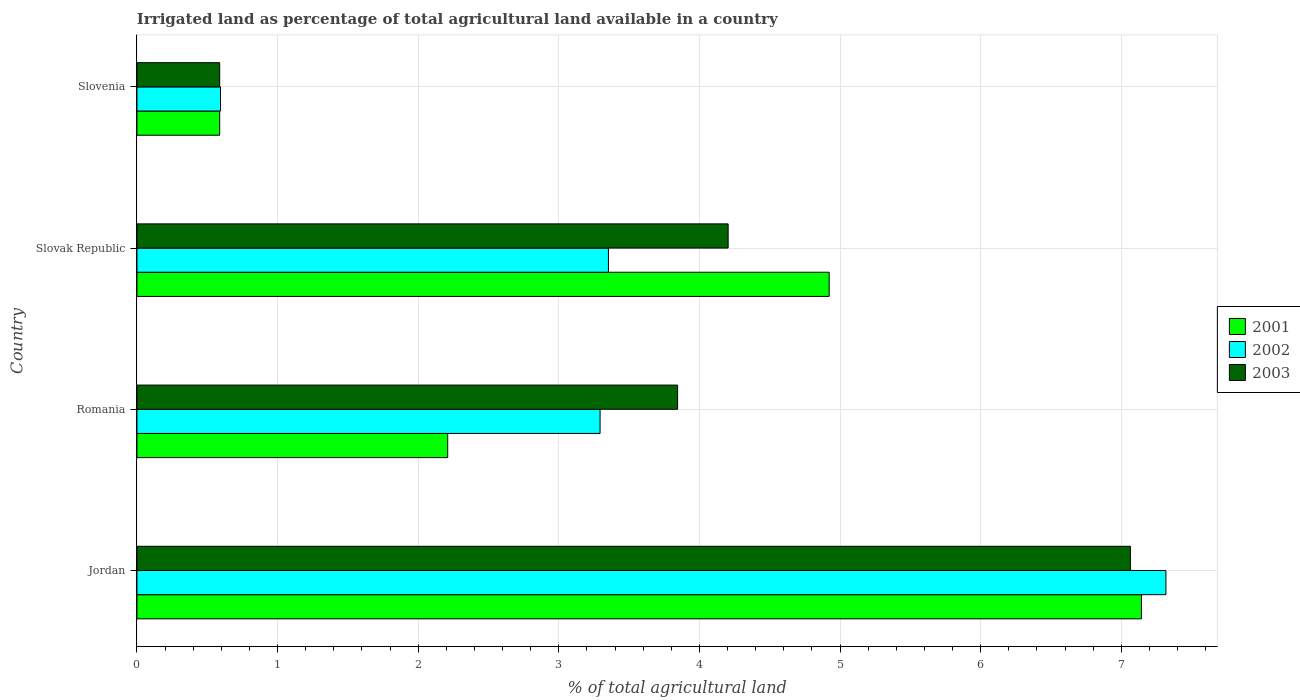Are the number of bars per tick equal to the number of legend labels?
Make the answer very short. Yes. What is the label of the 3rd group of bars from the top?
Your answer should be compact. Romania. In how many cases, is the number of bars for a given country not equal to the number of legend labels?
Provide a succinct answer. 0. What is the percentage of irrigated land in 2002 in Slovak Republic?
Provide a short and direct response. 3.35. Across all countries, what is the maximum percentage of irrigated land in 2001?
Offer a very short reply. 7.14. Across all countries, what is the minimum percentage of irrigated land in 2003?
Offer a very short reply. 0.59. In which country was the percentage of irrigated land in 2001 maximum?
Offer a terse response. Jordan. In which country was the percentage of irrigated land in 2001 minimum?
Your answer should be very brief. Slovenia. What is the total percentage of irrigated land in 2003 in the graph?
Provide a succinct answer. 15.7. What is the difference between the percentage of irrigated land in 2003 in Jordan and that in Romania?
Your answer should be compact. 3.22. What is the difference between the percentage of irrigated land in 2003 in Jordan and the percentage of irrigated land in 2002 in Slovenia?
Your response must be concise. 6.47. What is the average percentage of irrigated land in 2002 per country?
Give a very brief answer. 3.64. What is the difference between the percentage of irrigated land in 2003 and percentage of irrigated land in 2001 in Slovenia?
Provide a succinct answer. 0. In how many countries, is the percentage of irrigated land in 2003 greater than 3.4 %?
Your answer should be compact. 3. What is the ratio of the percentage of irrigated land in 2003 in Jordan to that in Slovenia?
Provide a short and direct response. 12.01. Is the difference between the percentage of irrigated land in 2003 in Slovak Republic and Slovenia greater than the difference between the percentage of irrigated land in 2001 in Slovak Republic and Slovenia?
Provide a short and direct response. No. What is the difference between the highest and the second highest percentage of irrigated land in 2003?
Make the answer very short. 2.86. What is the difference between the highest and the lowest percentage of irrigated land in 2001?
Offer a terse response. 6.55. In how many countries, is the percentage of irrigated land in 2003 greater than the average percentage of irrigated land in 2003 taken over all countries?
Ensure brevity in your answer.  2. What does the 2nd bar from the top in Jordan represents?
Offer a very short reply. 2002. Is it the case that in every country, the sum of the percentage of irrigated land in 2001 and percentage of irrigated land in 2003 is greater than the percentage of irrigated land in 2002?
Your answer should be very brief. Yes. How many bars are there?
Ensure brevity in your answer.  12. How many countries are there in the graph?
Keep it short and to the point. 4. Are the values on the major ticks of X-axis written in scientific E-notation?
Give a very brief answer. No. What is the title of the graph?
Keep it short and to the point. Irrigated land as percentage of total agricultural land available in a country. Does "2009" appear as one of the legend labels in the graph?
Your answer should be very brief. No. What is the label or title of the X-axis?
Make the answer very short. % of total agricultural land. What is the % of total agricultural land of 2001 in Jordan?
Provide a succinct answer. 7.14. What is the % of total agricultural land in 2002 in Jordan?
Keep it short and to the point. 7.32. What is the % of total agricultural land in 2003 in Jordan?
Provide a short and direct response. 7.06. What is the % of total agricultural land of 2001 in Romania?
Provide a short and direct response. 2.21. What is the % of total agricultural land in 2002 in Romania?
Ensure brevity in your answer.  3.29. What is the % of total agricultural land in 2003 in Romania?
Offer a terse response. 3.84. What is the % of total agricultural land in 2001 in Slovak Republic?
Provide a short and direct response. 4.92. What is the % of total agricultural land in 2002 in Slovak Republic?
Provide a short and direct response. 3.35. What is the % of total agricultural land of 2003 in Slovak Republic?
Offer a terse response. 4.2. What is the % of total agricultural land of 2001 in Slovenia?
Your response must be concise. 0.59. What is the % of total agricultural land in 2002 in Slovenia?
Provide a succinct answer. 0.59. What is the % of total agricultural land of 2003 in Slovenia?
Give a very brief answer. 0.59. Across all countries, what is the maximum % of total agricultural land in 2001?
Provide a succinct answer. 7.14. Across all countries, what is the maximum % of total agricultural land of 2002?
Provide a short and direct response. 7.32. Across all countries, what is the maximum % of total agricultural land in 2003?
Offer a very short reply. 7.06. Across all countries, what is the minimum % of total agricultural land of 2001?
Provide a succinct answer. 0.59. Across all countries, what is the minimum % of total agricultural land in 2002?
Make the answer very short. 0.59. Across all countries, what is the minimum % of total agricultural land in 2003?
Give a very brief answer. 0.59. What is the total % of total agricultural land of 2001 in the graph?
Ensure brevity in your answer.  14.86. What is the total % of total agricultural land of 2002 in the graph?
Your answer should be very brief. 14.56. What is the total % of total agricultural land in 2003 in the graph?
Your response must be concise. 15.7. What is the difference between the % of total agricultural land in 2001 in Jordan and that in Romania?
Give a very brief answer. 4.93. What is the difference between the % of total agricultural land in 2002 in Jordan and that in Romania?
Make the answer very short. 4.02. What is the difference between the % of total agricultural land of 2003 in Jordan and that in Romania?
Offer a very short reply. 3.22. What is the difference between the % of total agricultural land in 2001 in Jordan and that in Slovak Republic?
Your response must be concise. 2.22. What is the difference between the % of total agricultural land of 2002 in Jordan and that in Slovak Republic?
Offer a terse response. 3.96. What is the difference between the % of total agricultural land of 2003 in Jordan and that in Slovak Republic?
Give a very brief answer. 2.86. What is the difference between the % of total agricultural land of 2001 in Jordan and that in Slovenia?
Keep it short and to the point. 6.55. What is the difference between the % of total agricultural land of 2002 in Jordan and that in Slovenia?
Your answer should be very brief. 6.72. What is the difference between the % of total agricultural land of 2003 in Jordan and that in Slovenia?
Your answer should be very brief. 6.48. What is the difference between the % of total agricultural land in 2001 in Romania and that in Slovak Republic?
Provide a succinct answer. -2.71. What is the difference between the % of total agricultural land in 2002 in Romania and that in Slovak Republic?
Give a very brief answer. -0.06. What is the difference between the % of total agricultural land in 2003 in Romania and that in Slovak Republic?
Ensure brevity in your answer.  -0.36. What is the difference between the % of total agricultural land in 2001 in Romania and that in Slovenia?
Give a very brief answer. 1.62. What is the difference between the % of total agricultural land in 2002 in Romania and that in Slovenia?
Provide a succinct answer. 2.7. What is the difference between the % of total agricultural land of 2003 in Romania and that in Slovenia?
Provide a succinct answer. 3.26. What is the difference between the % of total agricultural land of 2001 in Slovak Republic and that in Slovenia?
Your answer should be very brief. 4.33. What is the difference between the % of total agricultural land of 2002 in Slovak Republic and that in Slovenia?
Keep it short and to the point. 2.76. What is the difference between the % of total agricultural land in 2003 in Slovak Republic and that in Slovenia?
Ensure brevity in your answer.  3.62. What is the difference between the % of total agricultural land of 2001 in Jordan and the % of total agricultural land of 2002 in Romania?
Keep it short and to the point. 3.85. What is the difference between the % of total agricultural land in 2001 in Jordan and the % of total agricultural land in 2003 in Romania?
Your answer should be very brief. 3.3. What is the difference between the % of total agricultural land in 2002 in Jordan and the % of total agricultural land in 2003 in Romania?
Offer a terse response. 3.47. What is the difference between the % of total agricultural land in 2001 in Jordan and the % of total agricultural land in 2002 in Slovak Republic?
Your answer should be very brief. 3.79. What is the difference between the % of total agricultural land of 2001 in Jordan and the % of total agricultural land of 2003 in Slovak Republic?
Your answer should be very brief. 2.94. What is the difference between the % of total agricultural land of 2002 in Jordan and the % of total agricultural land of 2003 in Slovak Republic?
Your answer should be very brief. 3.11. What is the difference between the % of total agricultural land of 2001 in Jordan and the % of total agricultural land of 2002 in Slovenia?
Your answer should be compact. 6.55. What is the difference between the % of total agricultural land of 2001 in Jordan and the % of total agricultural land of 2003 in Slovenia?
Your response must be concise. 6.55. What is the difference between the % of total agricultural land in 2002 in Jordan and the % of total agricultural land in 2003 in Slovenia?
Offer a very short reply. 6.73. What is the difference between the % of total agricultural land in 2001 in Romania and the % of total agricultural land in 2002 in Slovak Republic?
Make the answer very short. -1.14. What is the difference between the % of total agricultural land in 2001 in Romania and the % of total agricultural land in 2003 in Slovak Republic?
Keep it short and to the point. -1.99. What is the difference between the % of total agricultural land in 2002 in Romania and the % of total agricultural land in 2003 in Slovak Republic?
Your answer should be very brief. -0.91. What is the difference between the % of total agricultural land of 2001 in Romania and the % of total agricultural land of 2002 in Slovenia?
Your answer should be very brief. 1.62. What is the difference between the % of total agricultural land of 2001 in Romania and the % of total agricultural land of 2003 in Slovenia?
Provide a short and direct response. 1.62. What is the difference between the % of total agricultural land in 2002 in Romania and the % of total agricultural land in 2003 in Slovenia?
Keep it short and to the point. 2.71. What is the difference between the % of total agricultural land of 2001 in Slovak Republic and the % of total agricultural land of 2002 in Slovenia?
Provide a short and direct response. 4.33. What is the difference between the % of total agricultural land in 2001 in Slovak Republic and the % of total agricultural land in 2003 in Slovenia?
Give a very brief answer. 4.33. What is the difference between the % of total agricultural land in 2002 in Slovak Republic and the % of total agricultural land in 2003 in Slovenia?
Your response must be concise. 2.76. What is the average % of total agricultural land of 2001 per country?
Keep it short and to the point. 3.72. What is the average % of total agricultural land of 2002 per country?
Offer a terse response. 3.64. What is the average % of total agricultural land in 2003 per country?
Ensure brevity in your answer.  3.93. What is the difference between the % of total agricultural land of 2001 and % of total agricultural land of 2002 in Jordan?
Ensure brevity in your answer.  -0.17. What is the difference between the % of total agricultural land of 2001 and % of total agricultural land of 2003 in Jordan?
Offer a terse response. 0.08. What is the difference between the % of total agricultural land of 2002 and % of total agricultural land of 2003 in Jordan?
Ensure brevity in your answer.  0.25. What is the difference between the % of total agricultural land of 2001 and % of total agricultural land of 2002 in Romania?
Provide a short and direct response. -1.08. What is the difference between the % of total agricultural land in 2001 and % of total agricultural land in 2003 in Romania?
Provide a succinct answer. -1.63. What is the difference between the % of total agricultural land of 2002 and % of total agricultural land of 2003 in Romania?
Offer a terse response. -0.55. What is the difference between the % of total agricultural land in 2001 and % of total agricultural land in 2002 in Slovak Republic?
Your answer should be very brief. 1.57. What is the difference between the % of total agricultural land in 2001 and % of total agricultural land in 2003 in Slovak Republic?
Keep it short and to the point. 0.72. What is the difference between the % of total agricultural land of 2002 and % of total agricultural land of 2003 in Slovak Republic?
Provide a short and direct response. -0.85. What is the difference between the % of total agricultural land in 2001 and % of total agricultural land in 2002 in Slovenia?
Keep it short and to the point. -0.01. What is the difference between the % of total agricultural land of 2002 and % of total agricultural land of 2003 in Slovenia?
Offer a very short reply. 0.01. What is the ratio of the % of total agricultural land of 2001 in Jordan to that in Romania?
Provide a short and direct response. 3.23. What is the ratio of the % of total agricultural land in 2002 in Jordan to that in Romania?
Provide a succinct answer. 2.22. What is the ratio of the % of total agricultural land of 2003 in Jordan to that in Romania?
Provide a succinct answer. 1.84. What is the ratio of the % of total agricultural land of 2001 in Jordan to that in Slovak Republic?
Give a very brief answer. 1.45. What is the ratio of the % of total agricultural land of 2002 in Jordan to that in Slovak Republic?
Give a very brief answer. 2.18. What is the ratio of the % of total agricultural land in 2003 in Jordan to that in Slovak Republic?
Your answer should be compact. 1.68. What is the ratio of the % of total agricultural land in 2001 in Jordan to that in Slovenia?
Your answer should be compact. 12.14. What is the ratio of the % of total agricultural land of 2002 in Jordan to that in Slovenia?
Your response must be concise. 12.32. What is the ratio of the % of total agricultural land in 2003 in Jordan to that in Slovenia?
Provide a succinct answer. 12.01. What is the ratio of the % of total agricultural land in 2001 in Romania to that in Slovak Republic?
Offer a very short reply. 0.45. What is the ratio of the % of total agricultural land in 2002 in Romania to that in Slovak Republic?
Your response must be concise. 0.98. What is the ratio of the % of total agricultural land in 2003 in Romania to that in Slovak Republic?
Your response must be concise. 0.91. What is the ratio of the % of total agricultural land in 2001 in Romania to that in Slovenia?
Your answer should be compact. 3.76. What is the ratio of the % of total agricultural land in 2002 in Romania to that in Slovenia?
Provide a short and direct response. 5.54. What is the ratio of the % of total agricultural land of 2003 in Romania to that in Slovenia?
Make the answer very short. 6.54. What is the ratio of the % of total agricultural land of 2001 in Slovak Republic to that in Slovenia?
Provide a succinct answer. 8.37. What is the ratio of the % of total agricultural land of 2002 in Slovak Republic to that in Slovenia?
Ensure brevity in your answer.  5.64. What is the ratio of the % of total agricultural land of 2003 in Slovak Republic to that in Slovenia?
Ensure brevity in your answer.  7.15. What is the difference between the highest and the second highest % of total agricultural land in 2001?
Give a very brief answer. 2.22. What is the difference between the highest and the second highest % of total agricultural land of 2002?
Ensure brevity in your answer.  3.96. What is the difference between the highest and the second highest % of total agricultural land of 2003?
Ensure brevity in your answer.  2.86. What is the difference between the highest and the lowest % of total agricultural land of 2001?
Offer a terse response. 6.55. What is the difference between the highest and the lowest % of total agricultural land in 2002?
Your answer should be compact. 6.72. What is the difference between the highest and the lowest % of total agricultural land in 2003?
Ensure brevity in your answer.  6.48. 